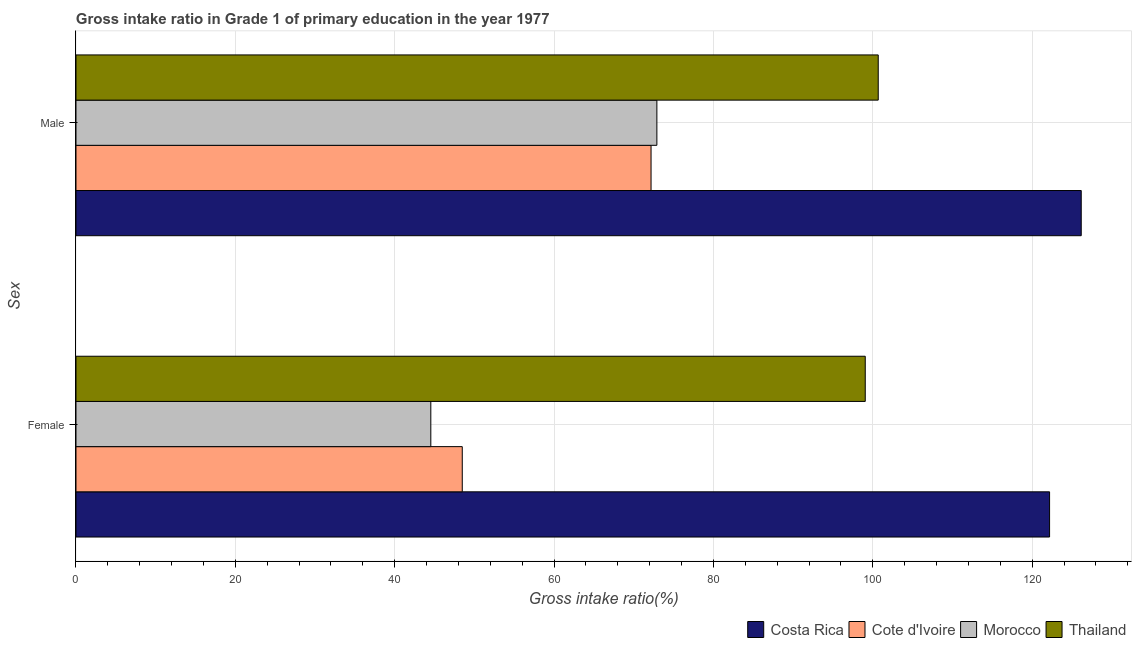How many different coloured bars are there?
Ensure brevity in your answer.  4. How many groups of bars are there?
Offer a terse response. 2. Are the number of bars per tick equal to the number of legend labels?
Keep it short and to the point. Yes. Are the number of bars on each tick of the Y-axis equal?
Your answer should be compact. Yes. How many bars are there on the 1st tick from the bottom?
Provide a succinct answer. 4. What is the label of the 1st group of bars from the top?
Provide a succinct answer. Male. What is the gross intake ratio(female) in Costa Rica?
Provide a succinct answer. 122.18. Across all countries, what is the maximum gross intake ratio(male)?
Keep it short and to the point. 126.15. Across all countries, what is the minimum gross intake ratio(male)?
Your response must be concise. 72.17. In which country was the gross intake ratio(male) minimum?
Offer a terse response. Cote d'Ivoire. What is the total gross intake ratio(female) in the graph?
Provide a short and direct response. 314.22. What is the difference between the gross intake ratio(female) in Thailand and that in Cote d'Ivoire?
Keep it short and to the point. 50.57. What is the difference between the gross intake ratio(female) in Thailand and the gross intake ratio(male) in Morocco?
Make the answer very short. 26.15. What is the average gross intake ratio(female) per country?
Your response must be concise. 78.56. What is the difference between the gross intake ratio(female) and gross intake ratio(male) in Costa Rica?
Make the answer very short. -3.97. What is the ratio of the gross intake ratio(female) in Cote d'Ivoire to that in Thailand?
Your response must be concise. 0.49. Is the gross intake ratio(male) in Costa Rica less than that in Cote d'Ivoire?
Your answer should be very brief. No. In how many countries, is the gross intake ratio(male) greater than the average gross intake ratio(male) taken over all countries?
Offer a very short reply. 2. What does the 3rd bar from the top in Female represents?
Give a very brief answer. Cote d'Ivoire. What does the 2nd bar from the bottom in Female represents?
Offer a very short reply. Cote d'Ivoire. How many bars are there?
Offer a terse response. 8. Are the values on the major ticks of X-axis written in scientific E-notation?
Offer a terse response. No. Does the graph contain any zero values?
Your response must be concise. No. Where does the legend appear in the graph?
Provide a short and direct response. Bottom right. What is the title of the graph?
Give a very brief answer. Gross intake ratio in Grade 1 of primary education in the year 1977. What is the label or title of the X-axis?
Keep it short and to the point. Gross intake ratio(%). What is the label or title of the Y-axis?
Keep it short and to the point. Sex. What is the Gross intake ratio(%) of Costa Rica in Female?
Ensure brevity in your answer.  122.18. What is the Gross intake ratio(%) in Cote d'Ivoire in Female?
Provide a short and direct response. 48.47. What is the Gross intake ratio(%) of Morocco in Female?
Make the answer very short. 44.53. What is the Gross intake ratio(%) of Thailand in Female?
Offer a very short reply. 99.05. What is the Gross intake ratio(%) of Costa Rica in Male?
Your answer should be very brief. 126.15. What is the Gross intake ratio(%) in Cote d'Ivoire in Male?
Offer a very short reply. 72.17. What is the Gross intake ratio(%) in Morocco in Male?
Offer a terse response. 72.9. What is the Gross intake ratio(%) in Thailand in Male?
Provide a succinct answer. 100.67. Across all Sex, what is the maximum Gross intake ratio(%) in Costa Rica?
Your response must be concise. 126.15. Across all Sex, what is the maximum Gross intake ratio(%) in Cote d'Ivoire?
Provide a short and direct response. 72.17. Across all Sex, what is the maximum Gross intake ratio(%) in Morocco?
Provide a short and direct response. 72.9. Across all Sex, what is the maximum Gross intake ratio(%) of Thailand?
Offer a very short reply. 100.67. Across all Sex, what is the minimum Gross intake ratio(%) of Costa Rica?
Provide a succinct answer. 122.18. Across all Sex, what is the minimum Gross intake ratio(%) in Cote d'Ivoire?
Provide a short and direct response. 48.47. Across all Sex, what is the minimum Gross intake ratio(%) of Morocco?
Your answer should be very brief. 44.53. Across all Sex, what is the minimum Gross intake ratio(%) of Thailand?
Ensure brevity in your answer.  99.05. What is the total Gross intake ratio(%) in Costa Rica in the graph?
Offer a terse response. 248.33. What is the total Gross intake ratio(%) in Cote d'Ivoire in the graph?
Make the answer very short. 120.64. What is the total Gross intake ratio(%) of Morocco in the graph?
Make the answer very short. 117.42. What is the total Gross intake ratio(%) of Thailand in the graph?
Keep it short and to the point. 199.72. What is the difference between the Gross intake ratio(%) in Costa Rica in Female and that in Male?
Your answer should be very brief. -3.97. What is the difference between the Gross intake ratio(%) in Cote d'Ivoire in Female and that in Male?
Your response must be concise. -23.69. What is the difference between the Gross intake ratio(%) of Morocco in Female and that in Male?
Your answer should be compact. -28.37. What is the difference between the Gross intake ratio(%) in Thailand in Female and that in Male?
Your answer should be very brief. -1.63. What is the difference between the Gross intake ratio(%) in Costa Rica in Female and the Gross intake ratio(%) in Cote d'Ivoire in Male?
Offer a very short reply. 50.01. What is the difference between the Gross intake ratio(%) in Costa Rica in Female and the Gross intake ratio(%) in Morocco in Male?
Offer a very short reply. 49.28. What is the difference between the Gross intake ratio(%) of Costa Rica in Female and the Gross intake ratio(%) of Thailand in Male?
Keep it short and to the point. 21.5. What is the difference between the Gross intake ratio(%) of Cote d'Ivoire in Female and the Gross intake ratio(%) of Morocco in Male?
Your answer should be compact. -24.42. What is the difference between the Gross intake ratio(%) in Cote d'Ivoire in Female and the Gross intake ratio(%) in Thailand in Male?
Give a very brief answer. -52.2. What is the difference between the Gross intake ratio(%) in Morocco in Female and the Gross intake ratio(%) in Thailand in Male?
Your answer should be compact. -56.15. What is the average Gross intake ratio(%) of Costa Rica per Sex?
Ensure brevity in your answer.  124.16. What is the average Gross intake ratio(%) in Cote d'Ivoire per Sex?
Provide a succinct answer. 60.32. What is the average Gross intake ratio(%) in Morocco per Sex?
Provide a short and direct response. 58.71. What is the average Gross intake ratio(%) of Thailand per Sex?
Ensure brevity in your answer.  99.86. What is the difference between the Gross intake ratio(%) of Costa Rica and Gross intake ratio(%) of Cote d'Ivoire in Female?
Ensure brevity in your answer.  73.7. What is the difference between the Gross intake ratio(%) in Costa Rica and Gross intake ratio(%) in Morocco in Female?
Your response must be concise. 77.65. What is the difference between the Gross intake ratio(%) of Costa Rica and Gross intake ratio(%) of Thailand in Female?
Ensure brevity in your answer.  23.13. What is the difference between the Gross intake ratio(%) in Cote d'Ivoire and Gross intake ratio(%) in Morocco in Female?
Keep it short and to the point. 3.95. What is the difference between the Gross intake ratio(%) in Cote d'Ivoire and Gross intake ratio(%) in Thailand in Female?
Your response must be concise. -50.57. What is the difference between the Gross intake ratio(%) in Morocco and Gross intake ratio(%) in Thailand in Female?
Offer a terse response. -54.52. What is the difference between the Gross intake ratio(%) in Costa Rica and Gross intake ratio(%) in Cote d'Ivoire in Male?
Your answer should be compact. 53.98. What is the difference between the Gross intake ratio(%) of Costa Rica and Gross intake ratio(%) of Morocco in Male?
Provide a short and direct response. 53.25. What is the difference between the Gross intake ratio(%) in Costa Rica and Gross intake ratio(%) in Thailand in Male?
Your answer should be very brief. 25.47. What is the difference between the Gross intake ratio(%) in Cote d'Ivoire and Gross intake ratio(%) in Morocco in Male?
Offer a very short reply. -0.73. What is the difference between the Gross intake ratio(%) of Cote d'Ivoire and Gross intake ratio(%) of Thailand in Male?
Give a very brief answer. -28.51. What is the difference between the Gross intake ratio(%) of Morocco and Gross intake ratio(%) of Thailand in Male?
Provide a short and direct response. -27.78. What is the ratio of the Gross intake ratio(%) of Costa Rica in Female to that in Male?
Your response must be concise. 0.97. What is the ratio of the Gross intake ratio(%) of Cote d'Ivoire in Female to that in Male?
Your response must be concise. 0.67. What is the ratio of the Gross intake ratio(%) in Morocco in Female to that in Male?
Your answer should be very brief. 0.61. What is the ratio of the Gross intake ratio(%) in Thailand in Female to that in Male?
Provide a short and direct response. 0.98. What is the difference between the highest and the second highest Gross intake ratio(%) of Costa Rica?
Make the answer very short. 3.97. What is the difference between the highest and the second highest Gross intake ratio(%) in Cote d'Ivoire?
Make the answer very short. 23.69. What is the difference between the highest and the second highest Gross intake ratio(%) of Morocco?
Ensure brevity in your answer.  28.37. What is the difference between the highest and the second highest Gross intake ratio(%) in Thailand?
Offer a terse response. 1.63. What is the difference between the highest and the lowest Gross intake ratio(%) in Costa Rica?
Your answer should be very brief. 3.97. What is the difference between the highest and the lowest Gross intake ratio(%) in Cote d'Ivoire?
Make the answer very short. 23.69. What is the difference between the highest and the lowest Gross intake ratio(%) of Morocco?
Give a very brief answer. 28.37. What is the difference between the highest and the lowest Gross intake ratio(%) in Thailand?
Your answer should be compact. 1.63. 